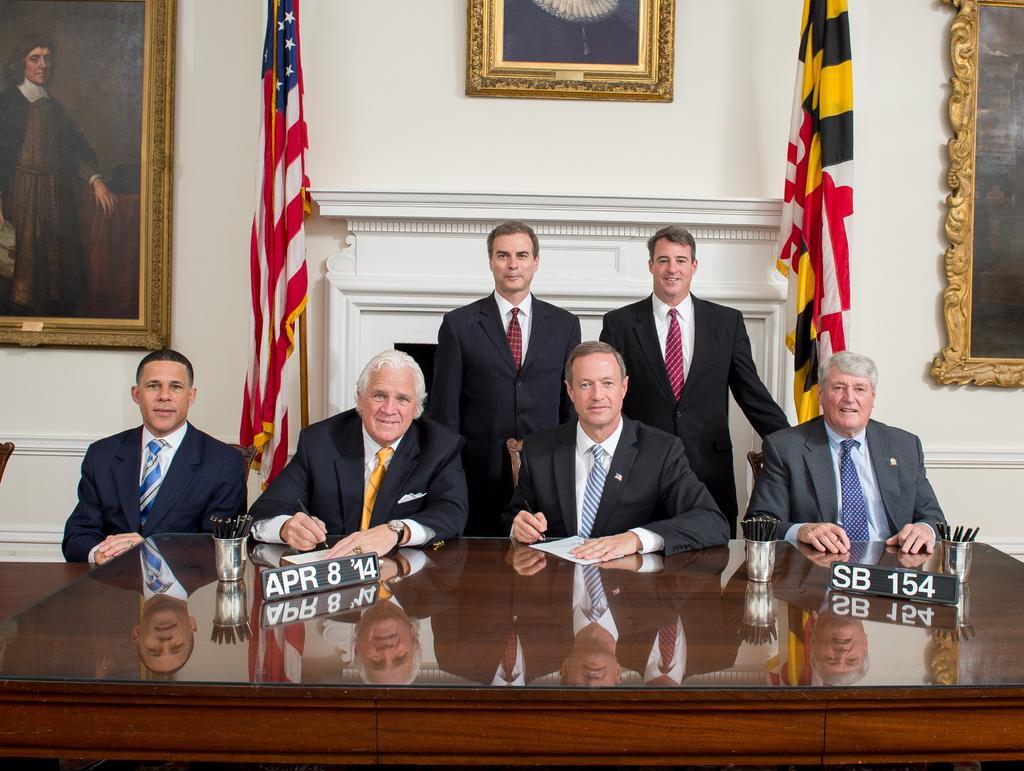Please provide a concise description of this image. Here in this picture we can see a group of men sitting on chairs and behind them we can see two men standing and all of them are wearing suits and smiling and in front of them we can see a table, on which we can see glasses present and we can see the two person s in the middle are signing the paper present in front of them and behind them we can see flag posts present on either side and we can also see portrait present on wall and we can also see some number plates present on the table. 